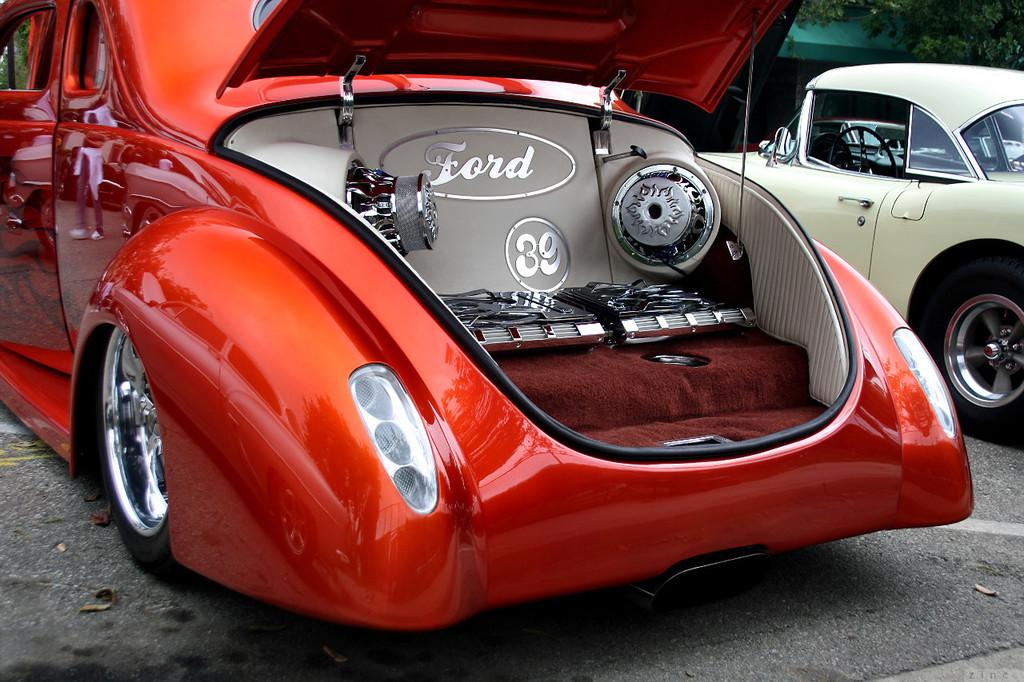<image>
Give a short and clear explanation of the subsequent image. Red concept Ford car being put on display outdoors. 